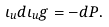<formula> <loc_0><loc_0><loc_500><loc_500>\iota _ { u } d \iota _ { u } g = - d P .</formula> 